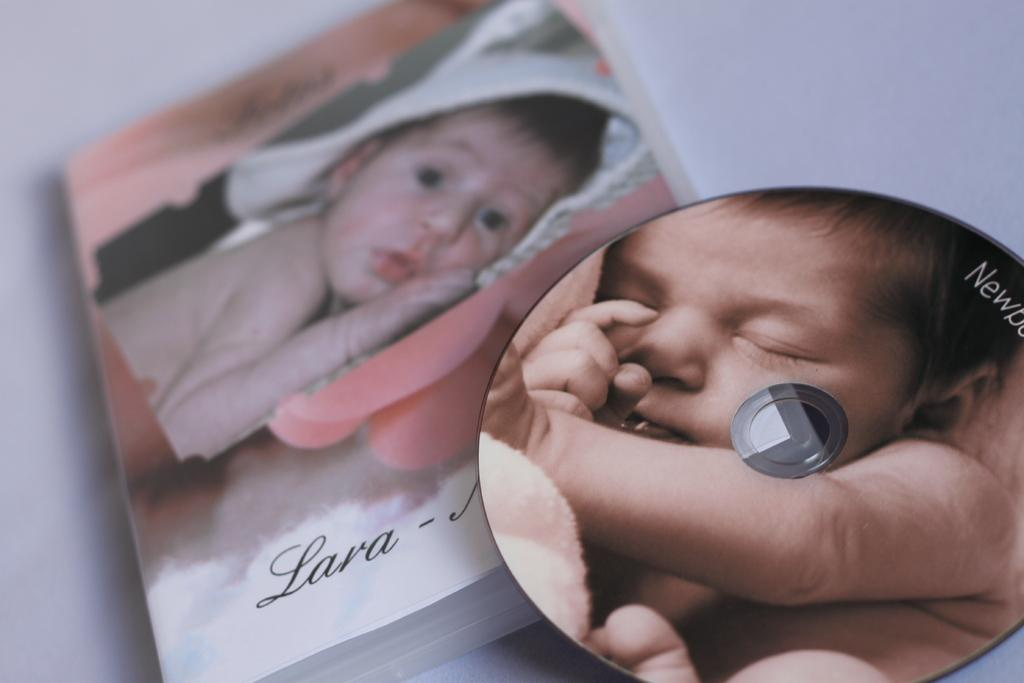What type of media is used to display the baby photos in the image? The baby photos are displayed on a cassette and a book in the image. Can you describe the two different baby photos in the image? One baby photo is on a cassette, and another baby photo is on a book. What type of lumber is used to build the kite in the image? There is no kite present in the image, so it is not possible to determine what type of lumber might be used to build it. 